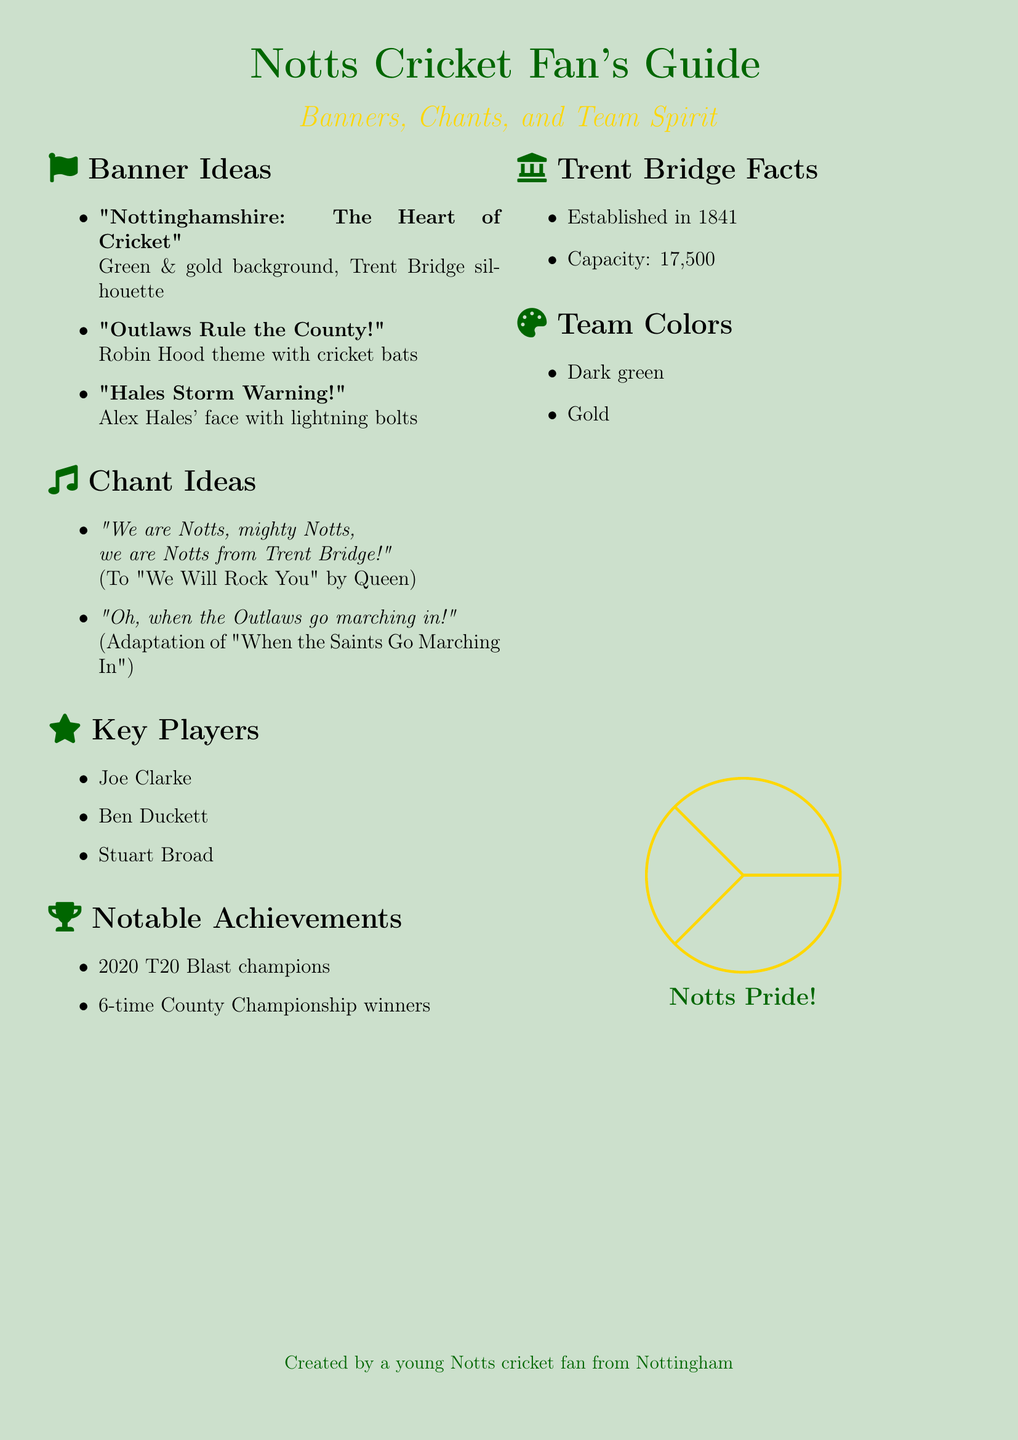What is the capacity of Trent Bridge? The document states that the capacity of Trent Bridge is 17,500.
Answer: 17,500 Who are the key players featured? The document lists Joe Clarke, Ben Duckett, and Stuart Broad as key players.
Answer: Joe Clarke, Ben Duckett, Stuart Broad What is the slogan for the banner design featuring Alex Hales? The slogan for the banner design is "Hales Storm Warning!"
Answer: Hales Storm Warning! How many times has Notts won the County Championship? The document mentions that Notts has won the County Championship 6 times.
Answer: 6 times What tune is the chant "We are Notts, mighty Notts..." based on? The chant is set to the melody of "We Will Rock You" by Queen.
Answer: We Will Rock You What color is NOT one of the team colors? The document indicates that the team colors include dark green and gold, but does not mention any other colors.
Answer: None (only dark green and gold are mentioned) What theme is used for the banner "Outlaws Rule the County!"? The theme for this banner design is Robin Hood.
Answer: Robin Hood theme In what year did Notts become T20 Blast champions? According to the document, Notts became T20 Blast champions in 2020.
Answer: 2020 